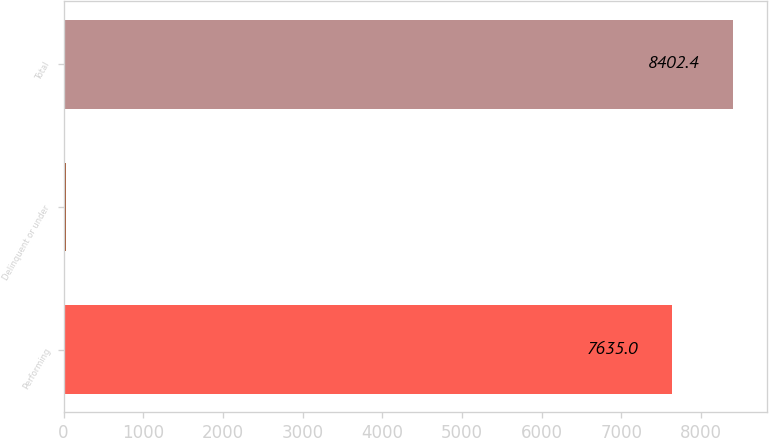<chart> <loc_0><loc_0><loc_500><loc_500><bar_chart><fcel>Performing<fcel>Delinquent or under<fcel>Total<nl><fcel>7635<fcel>37<fcel>8402.4<nl></chart> 